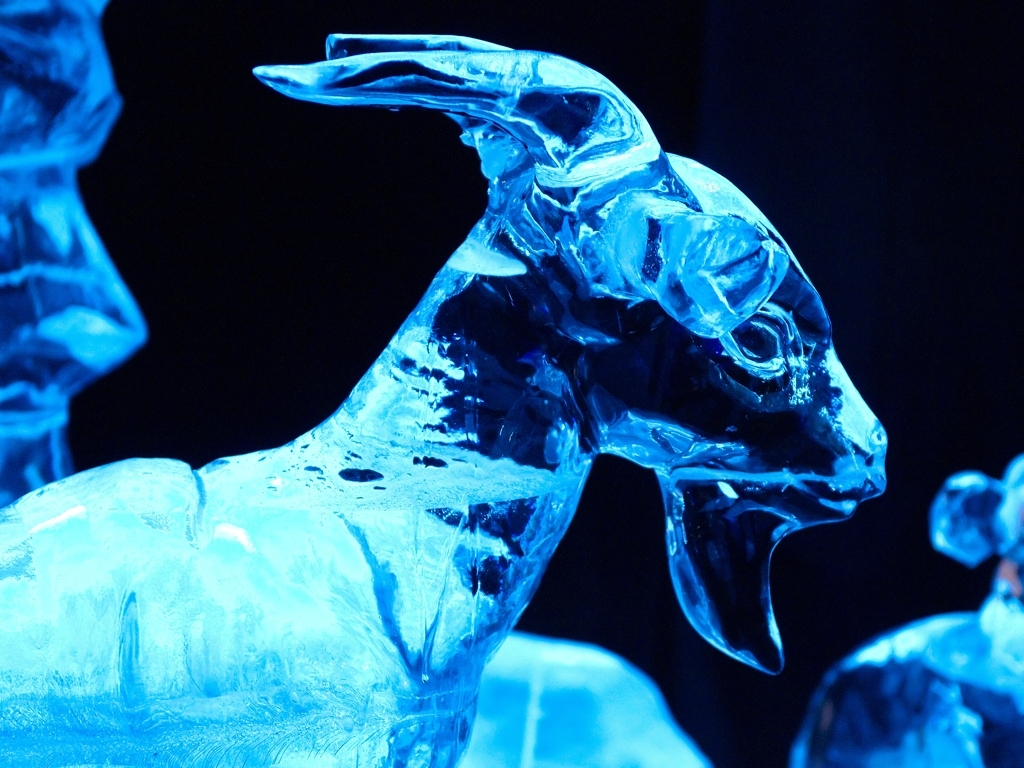Can you describe the lighting and how it contributes to the sculpture's appearance? The sculpture is illuminated by a blue light, which gives it an ethereal glow and enhances its icy characteristics. The strategic placement of the light source accentuates the curves, edges, and etched details of the sculpture, creating a contrast between the blue-lit areas and the shadows. This type of lighting not only brings out the texture and three-dimensionality of the sculpture but also contributes to the overall mood, suggesting an otherworldly or magical ambiance. 